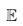<formula> <loc_0><loc_0><loc_500><loc_500>\mathbb { E }</formula> 